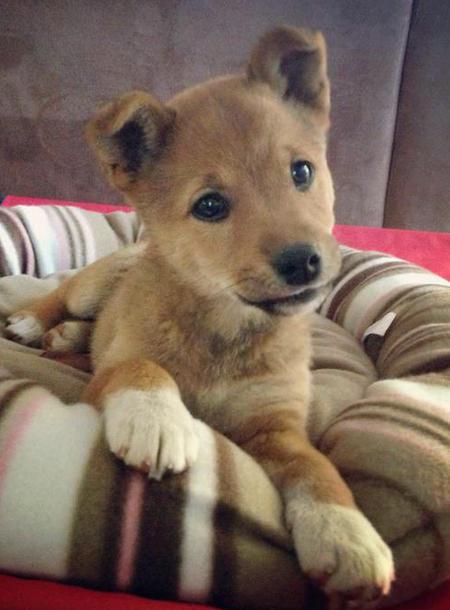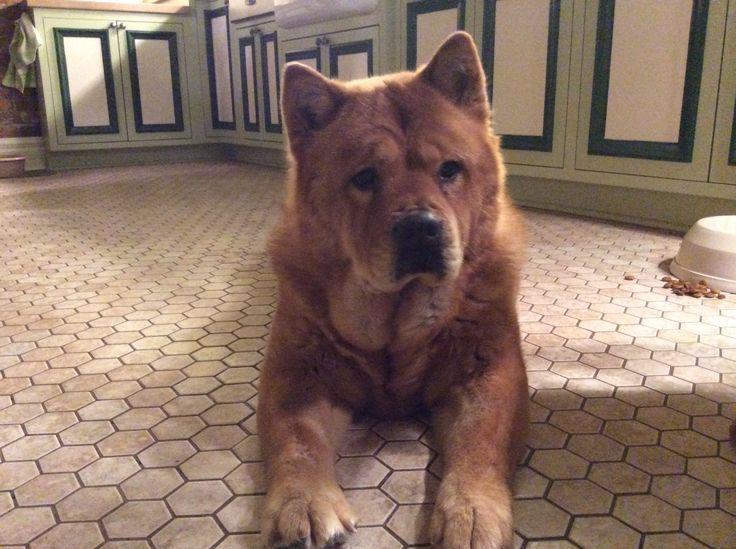The first image is the image on the left, the second image is the image on the right. Analyze the images presented: Is the assertion "The dog in the image on the right is lying down." valid? Answer yes or no. Yes. 